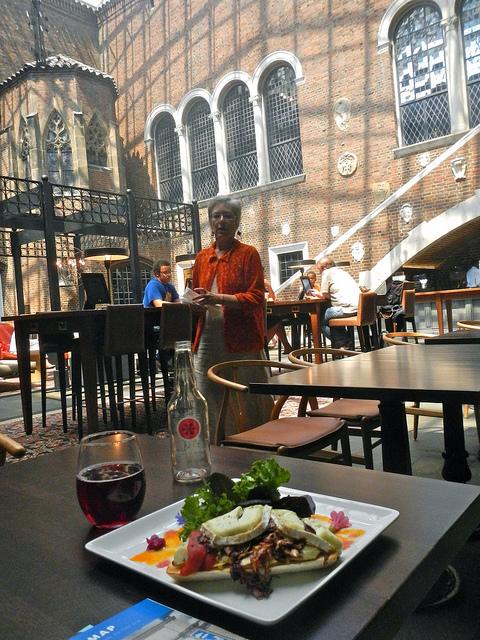What color is the plate?
Quick response, please. White. What shape is the plate?
Write a very short answer. Square. Is there someone currently eating the plate of food in the foreground?
Keep it brief. No. 